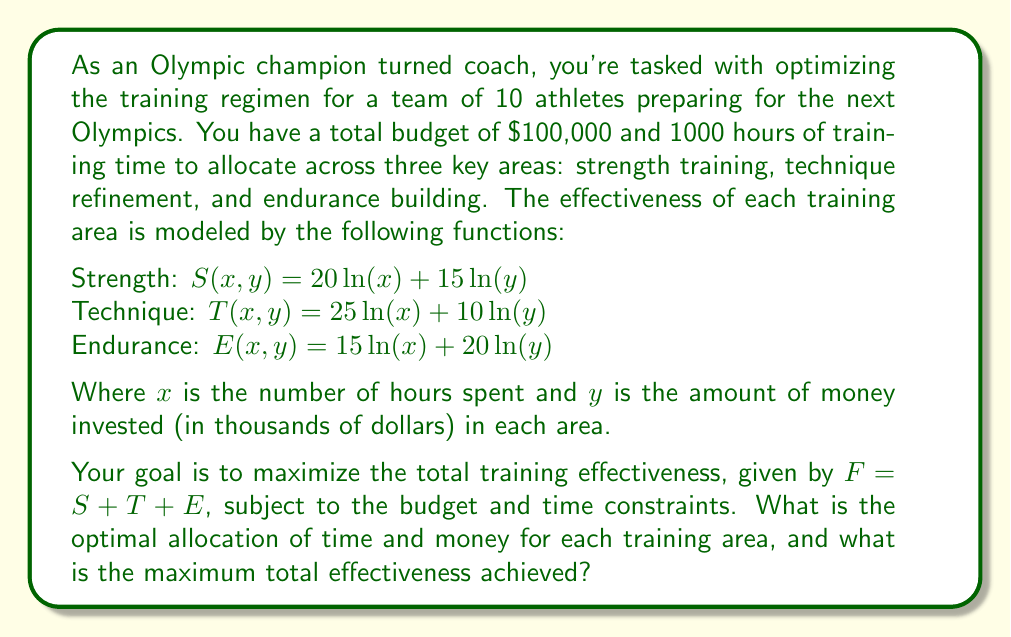Give your solution to this math problem. To solve this optimization problem, we'll use the method of Lagrange multipliers. Let's define our objective function and constraints:

Objective function: 
$$F = S + T + E = (20\ln(x_1) + 15\ln(y_1)) + (25\ln(x_2) + 10\ln(y_2)) + (15\ln(x_3) + 20\ln(y_3))$$

Constraints:
1. Time constraint: $x_1 + x_2 + x_3 = 1000$
2. Budget constraint: $y_1 + y_2 + y_3 = 100$

Let's form the Lagrangian:

$$L = F + \lambda(1000 - x_1 - x_2 - x_3) + \mu(100 - y_1 - y_2 - y_3)$$

Now, we take partial derivatives and set them equal to zero:

$$\frac{\partial L}{\partial x_1} = \frac{20}{x_1} - \lambda = 0$$
$$\frac{\partial L}{\partial x_2} = \frac{25}{x_2} - \lambda = 0$$
$$\frac{\partial L}{\partial x_3} = \frac{15}{x_3} - \lambda = 0$$
$$\frac{\partial L}{\partial y_1} = \frac{15}{y_1} - \mu = 0$$
$$\frac{\partial L}{\partial y_2} = \frac{10}{y_2} - \mu = 0$$
$$\frac{\partial L}{\partial y_3} = \frac{20}{y_3} - \mu = 0$$

From these equations, we can derive:

$$x_1 : x_2 : x_3 = 20 : 25 : 15$$
$$y_1 : y_2 : y_3 = 15 : 10 : 20$$

Using the constraints, we can solve for the actual values:

$$x_1 = \frac{20}{60} \cdot 1000 = 333.33$$
$$x_2 = \frac{25}{60} \cdot 1000 = 416.67$$
$$x_3 = \frac{15}{60} \cdot 1000 = 250$$

$$y_1 = \frac{15}{45} \cdot 100 = 33.33$$
$$y_2 = \frac{10}{45} \cdot 100 = 22.22$$
$$y_3 = \frac{20}{45} \cdot 100 = 44.44$$

To calculate the maximum total effectiveness, we substitute these values into our original function F:

$$F = (20\ln(333.33) + 15\ln(33.33)) + (25\ln(416.67) + 10\ln(22.22)) + (15\ln(250) + 20\ln(44.44))$$
Answer: The optimal allocation is:

Strength training: 333.33 hours and $33,330
Technique refinement: 416.67 hours and $22,220
Endurance building: 250 hours and $44,440

The maximum total effectiveness achieved is approximately 699.32. 